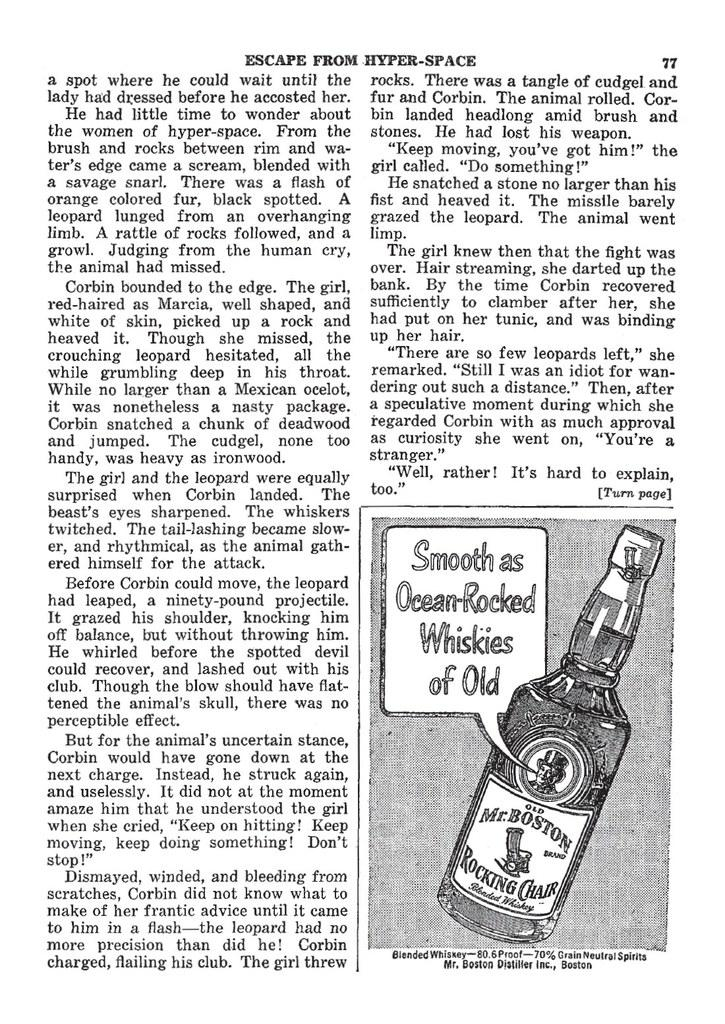Provide a one-sentence caption for the provided image. a print of a page with a bottle of Mr Boston whiskey pictured. 